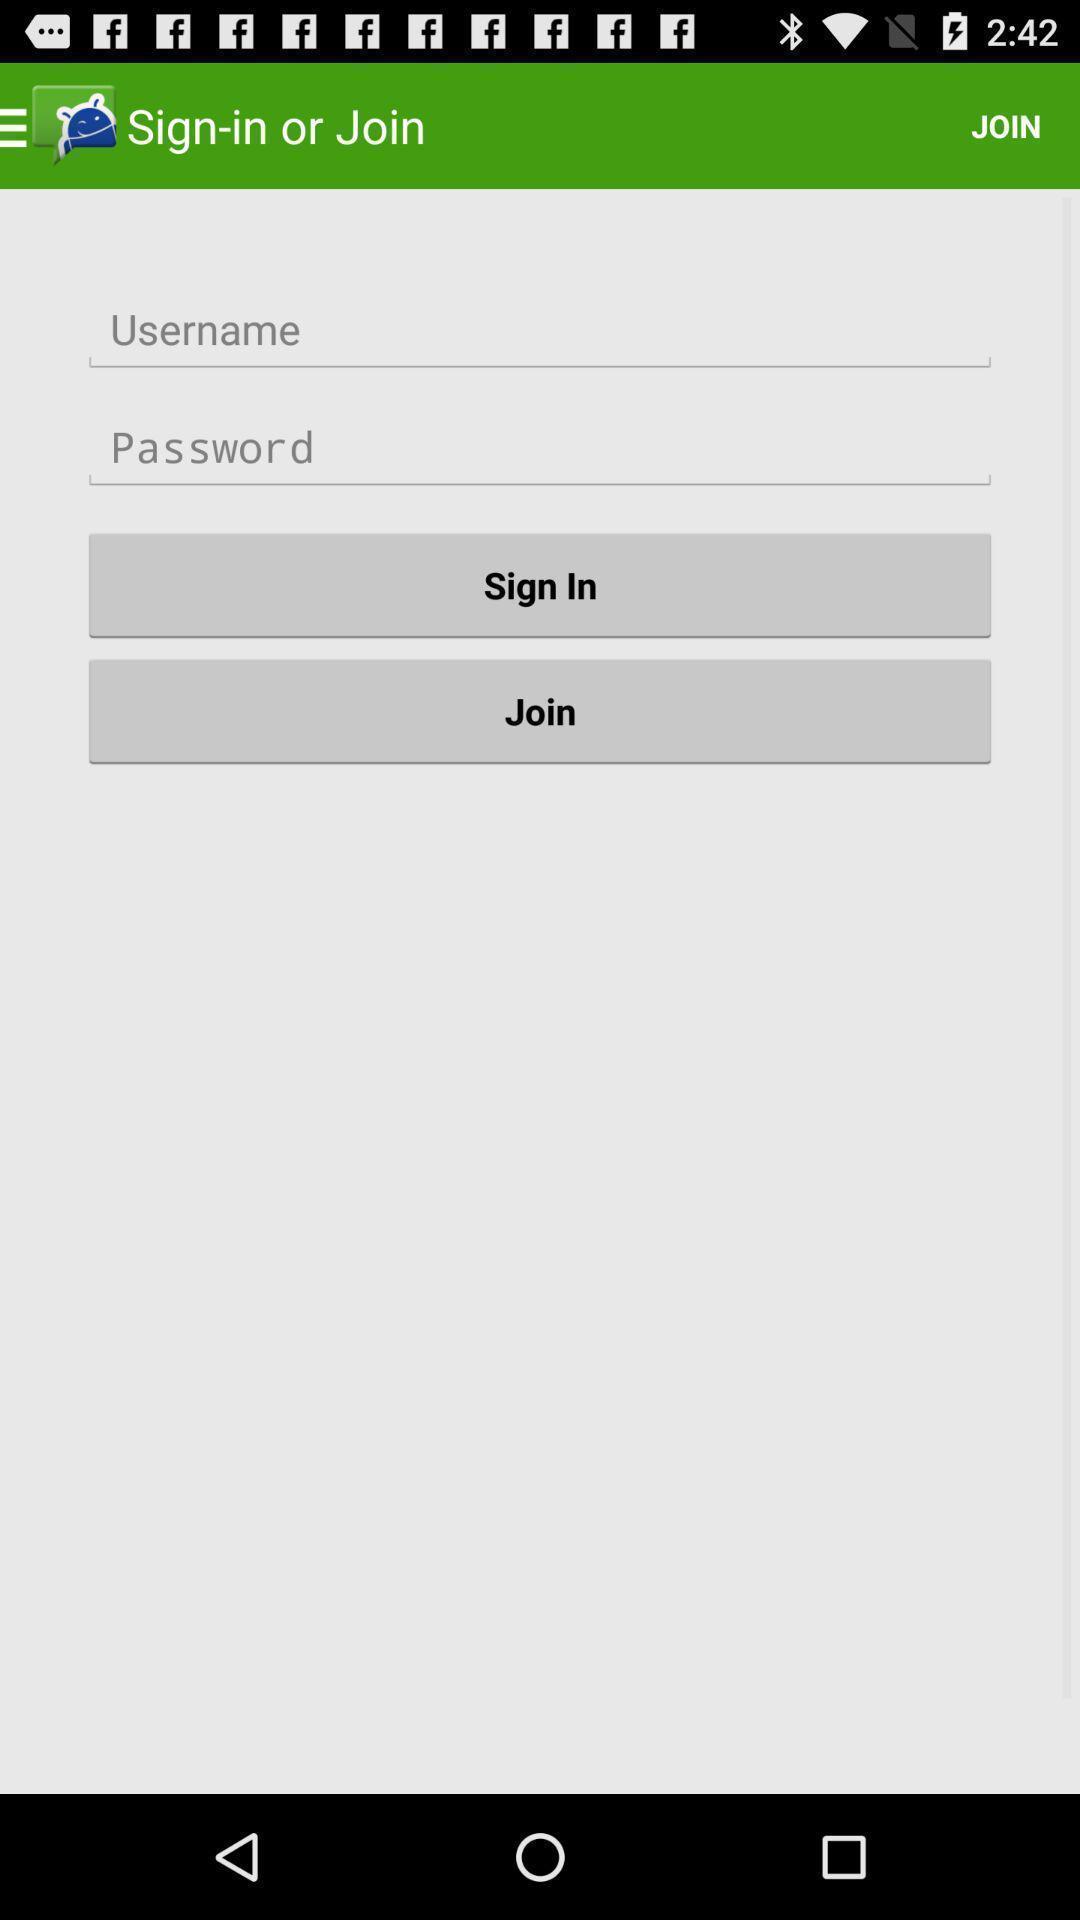Describe the key features of this screenshot. Sign in page. 